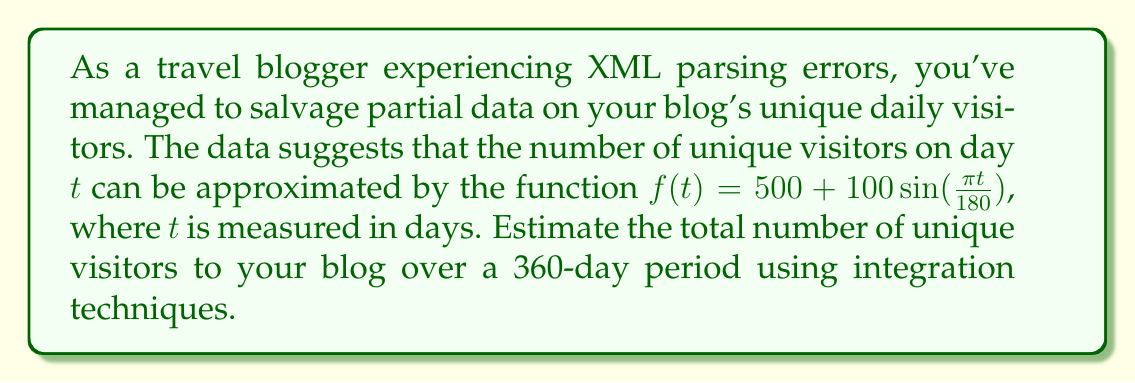Provide a solution to this math problem. To solve this problem, we need to integrate the given function over the specified time period. Here's a step-by-step approach:

1) The function representing daily unique visitors is:
   $$f(t) = 500 + 100\sin(\frac{\pi t}{180})$$

2) To find the total number of visitors over 360 days, we need to integrate this function from $t=0$ to $t=360$:
   $$\int_0^{360} (500 + 100\sin(\frac{\pi t}{180})) dt$$

3) Let's break this into two parts:
   $$\int_0^{360} 500 dt + \int_0^{360} 100\sin(\frac{\pi t}{180}) dt$$

4) For the first part:
   $$\int_0^{360} 500 dt = 500t \bigg|_0^{360} = 500(360) - 500(0) = 180,000$$

5) For the second part, we use the substitution $u = \frac{\pi t}{180}$:
   $$\frac{100 \cdot 180}{\pi} \int_0^{2\pi} \sin(u) du$$

6) Evaluating this integral:
   $$\frac{18000}{\pi} [-\cos(u)]_0^{2\pi} = \frac{18000}{\pi} [-\cos(2\pi) + \cos(0)] = 0$$

7) Adding the results from steps 4 and 6:
   $$180,000 + 0 = 180,000$$

Therefore, the estimated total number of unique visitors over 360 days is 180,000.
Answer: 180,000 unique visitors 